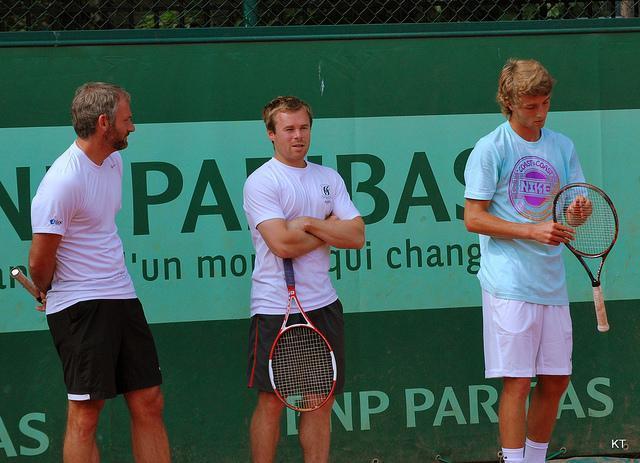How many men are in the picture?
Give a very brief answer. 3. How many people can you see?
Give a very brief answer. 3. How many tennis rackets are in the photo?
Give a very brief answer. 2. 